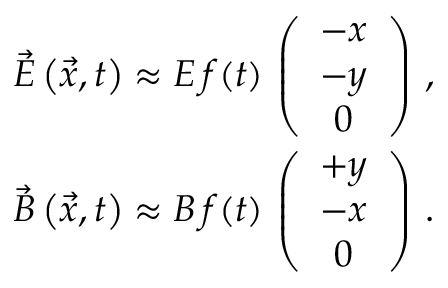<formula> <loc_0><loc_0><loc_500><loc_500>\begin{array} { r l r } & { \vec { E } \left ( \vec { x } , t \right ) \approx E \, f ( t ) \, \left ( \begin{array} { c } { - x } \\ { - y } \\ { 0 } \end{array} \right ) \, , } \\ & { \vec { B } \left ( \vec { x } , t \right ) \approx B \, f ( t ) \, \left ( \begin{array} { c } { + y } \\ { - x } \\ { 0 } \end{array} \right ) \, . } \end{array}</formula> 